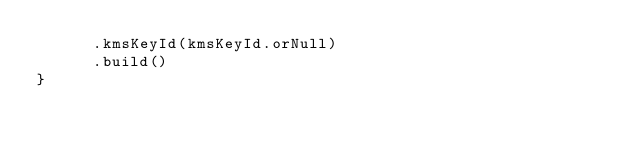Convert code to text. <code><loc_0><loc_0><loc_500><loc_500><_Scala_>      .kmsKeyId(kmsKeyId.orNull)
      .build()
}
</code> 